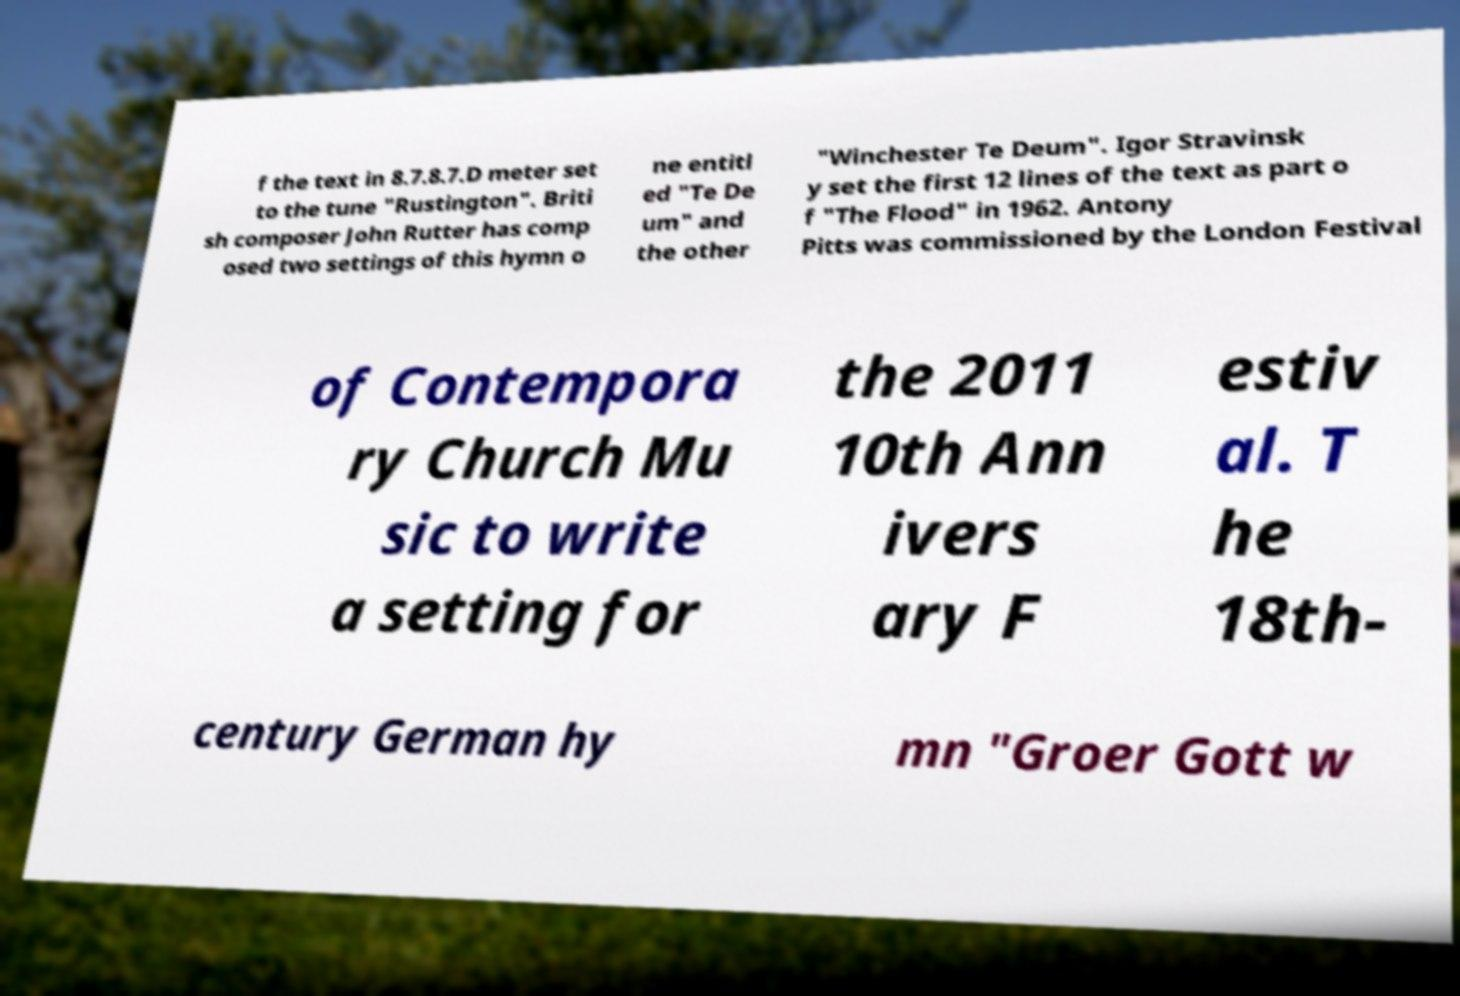There's text embedded in this image that I need extracted. Can you transcribe it verbatim? f the text in 8.7.8.7.D meter set to the tune "Rustington". Briti sh composer John Rutter has comp osed two settings of this hymn o ne entitl ed "Te De um" and the other "Winchester Te Deum". Igor Stravinsk y set the first 12 lines of the text as part o f "The Flood" in 1962. Antony Pitts was commissioned by the London Festival of Contempora ry Church Mu sic to write a setting for the 2011 10th Ann ivers ary F estiv al. T he 18th- century German hy mn "Groer Gott w 